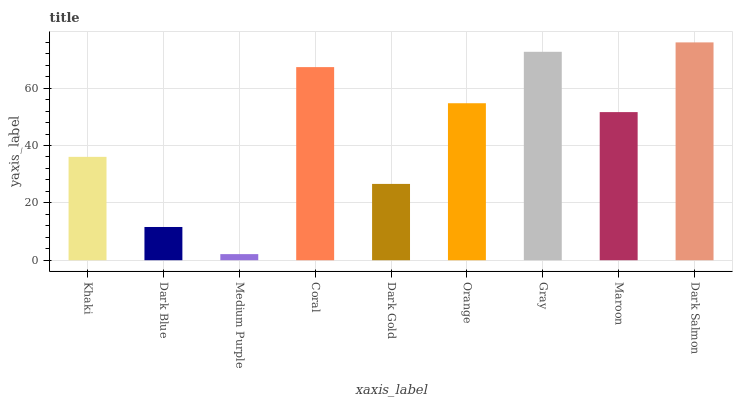Is Medium Purple the minimum?
Answer yes or no. Yes. Is Dark Salmon the maximum?
Answer yes or no. Yes. Is Dark Blue the minimum?
Answer yes or no. No. Is Dark Blue the maximum?
Answer yes or no. No. Is Khaki greater than Dark Blue?
Answer yes or no. Yes. Is Dark Blue less than Khaki?
Answer yes or no. Yes. Is Dark Blue greater than Khaki?
Answer yes or no. No. Is Khaki less than Dark Blue?
Answer yes or no. No. Is Maroon the high median?
Answer yes or no. Yes. Is Maroon the low median?
Answer yes or no. Yes. Is Coral the high median?
Answer yes or no. No. Is Coral the low median?
Answer yes or no. No. 